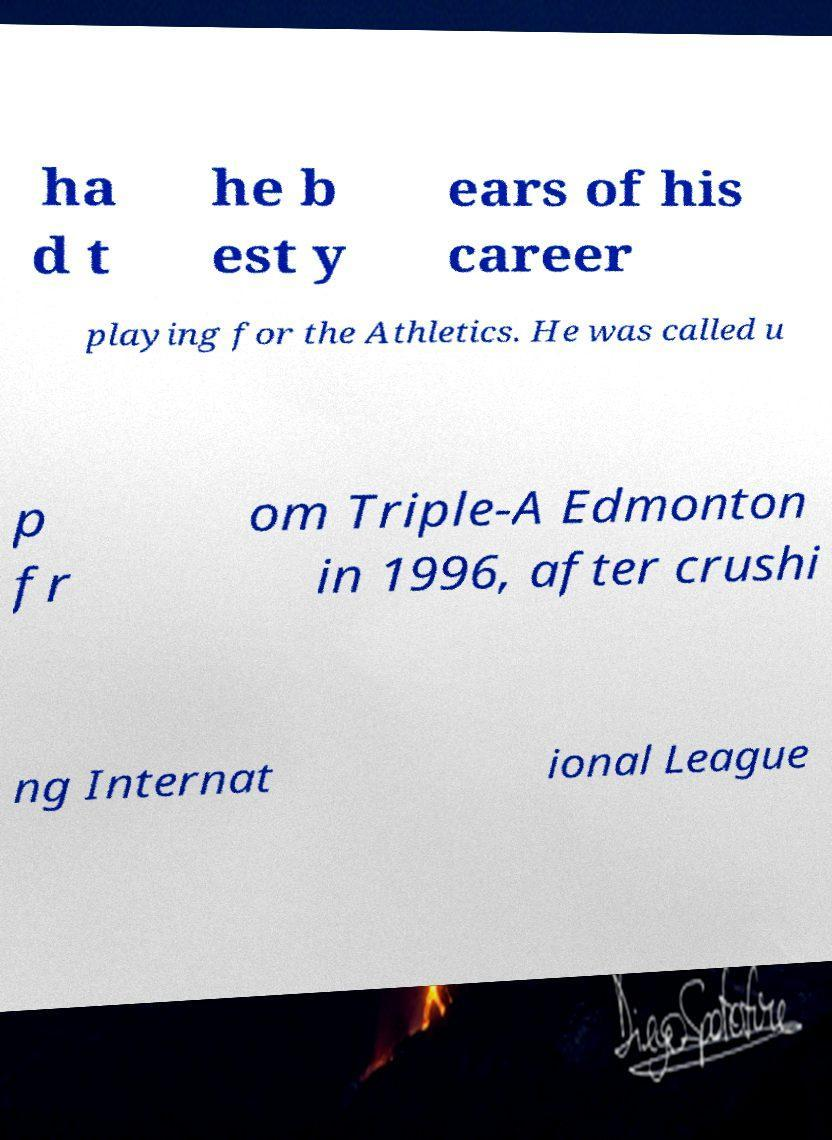Could you extract and type out the text from this image? ha d t he b est y ears of his career playing for the Athletics. He was called u p fr om Triple-A Edmonton in 1996, after crushi ng Internat ional League 